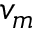<formula> <loc_0><loc_0><loc_500><loc_500>v _ { m }</formula> 